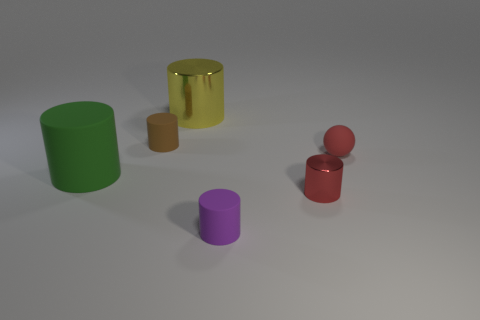What is the color of the small object behind the rubber thing right of the red metal cylinder?
Ensure brevity in your answer.  Brown. There is a rubber object that is left of the tiny ball and behind the large rubber object; how big is it?
Offer a very short reply. Small. Are there any other things that have the same color as the rubber sphere?
Keep it short and to the point. Yes. There is a brown object that is the same material as the small purple cylinder; what is its shape?
Provide a short and direct response. Cylinder. Do the brown object and the shiny object that is left of the purple cylinder have the same shape?
Ensure brevity in your answer.  Yes. There is a cylinder right of the small rubber cylinder right of the large metallic cylinder; what is it made of?
Offer a very short reply. Metal. Are there an equal number of tiny purple rubber objects behind the small purple cylinder and cyan matte cubes?
Give a very brief answer. Yes. Are there any other things that have the same material as the small purple cylinder?
Ensure brevity in your answer.  Yes. Do the metal object in front of the red matte thing and the matte object that is behind the tiny red matte sphere have the same color?
Your answer should be very brief. No. What number of cylinders are both in front of the ball and to the right of the green cylinder?
Provide a short and direct response. 2. 